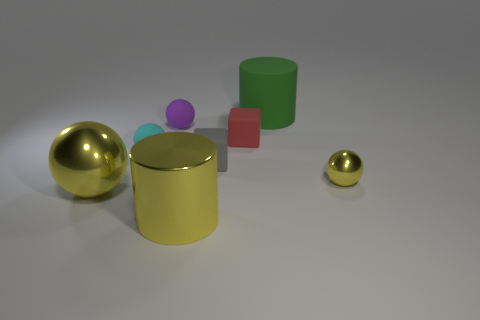Add 1 small red cubes. How many objects exist? 9 Subtract all blocks. How many objects are left? 6 Add 5 gray matte objects. How many gray matte objects are left? 6 Add 2 yellow metallic cylinders. How many yellow metallic cylinders exist? 3 Subtract 1 gray blocks. How many objects are left? 7 Subtract all cubes. Subtract all tiny purple matte things. How many objects are left? 5 